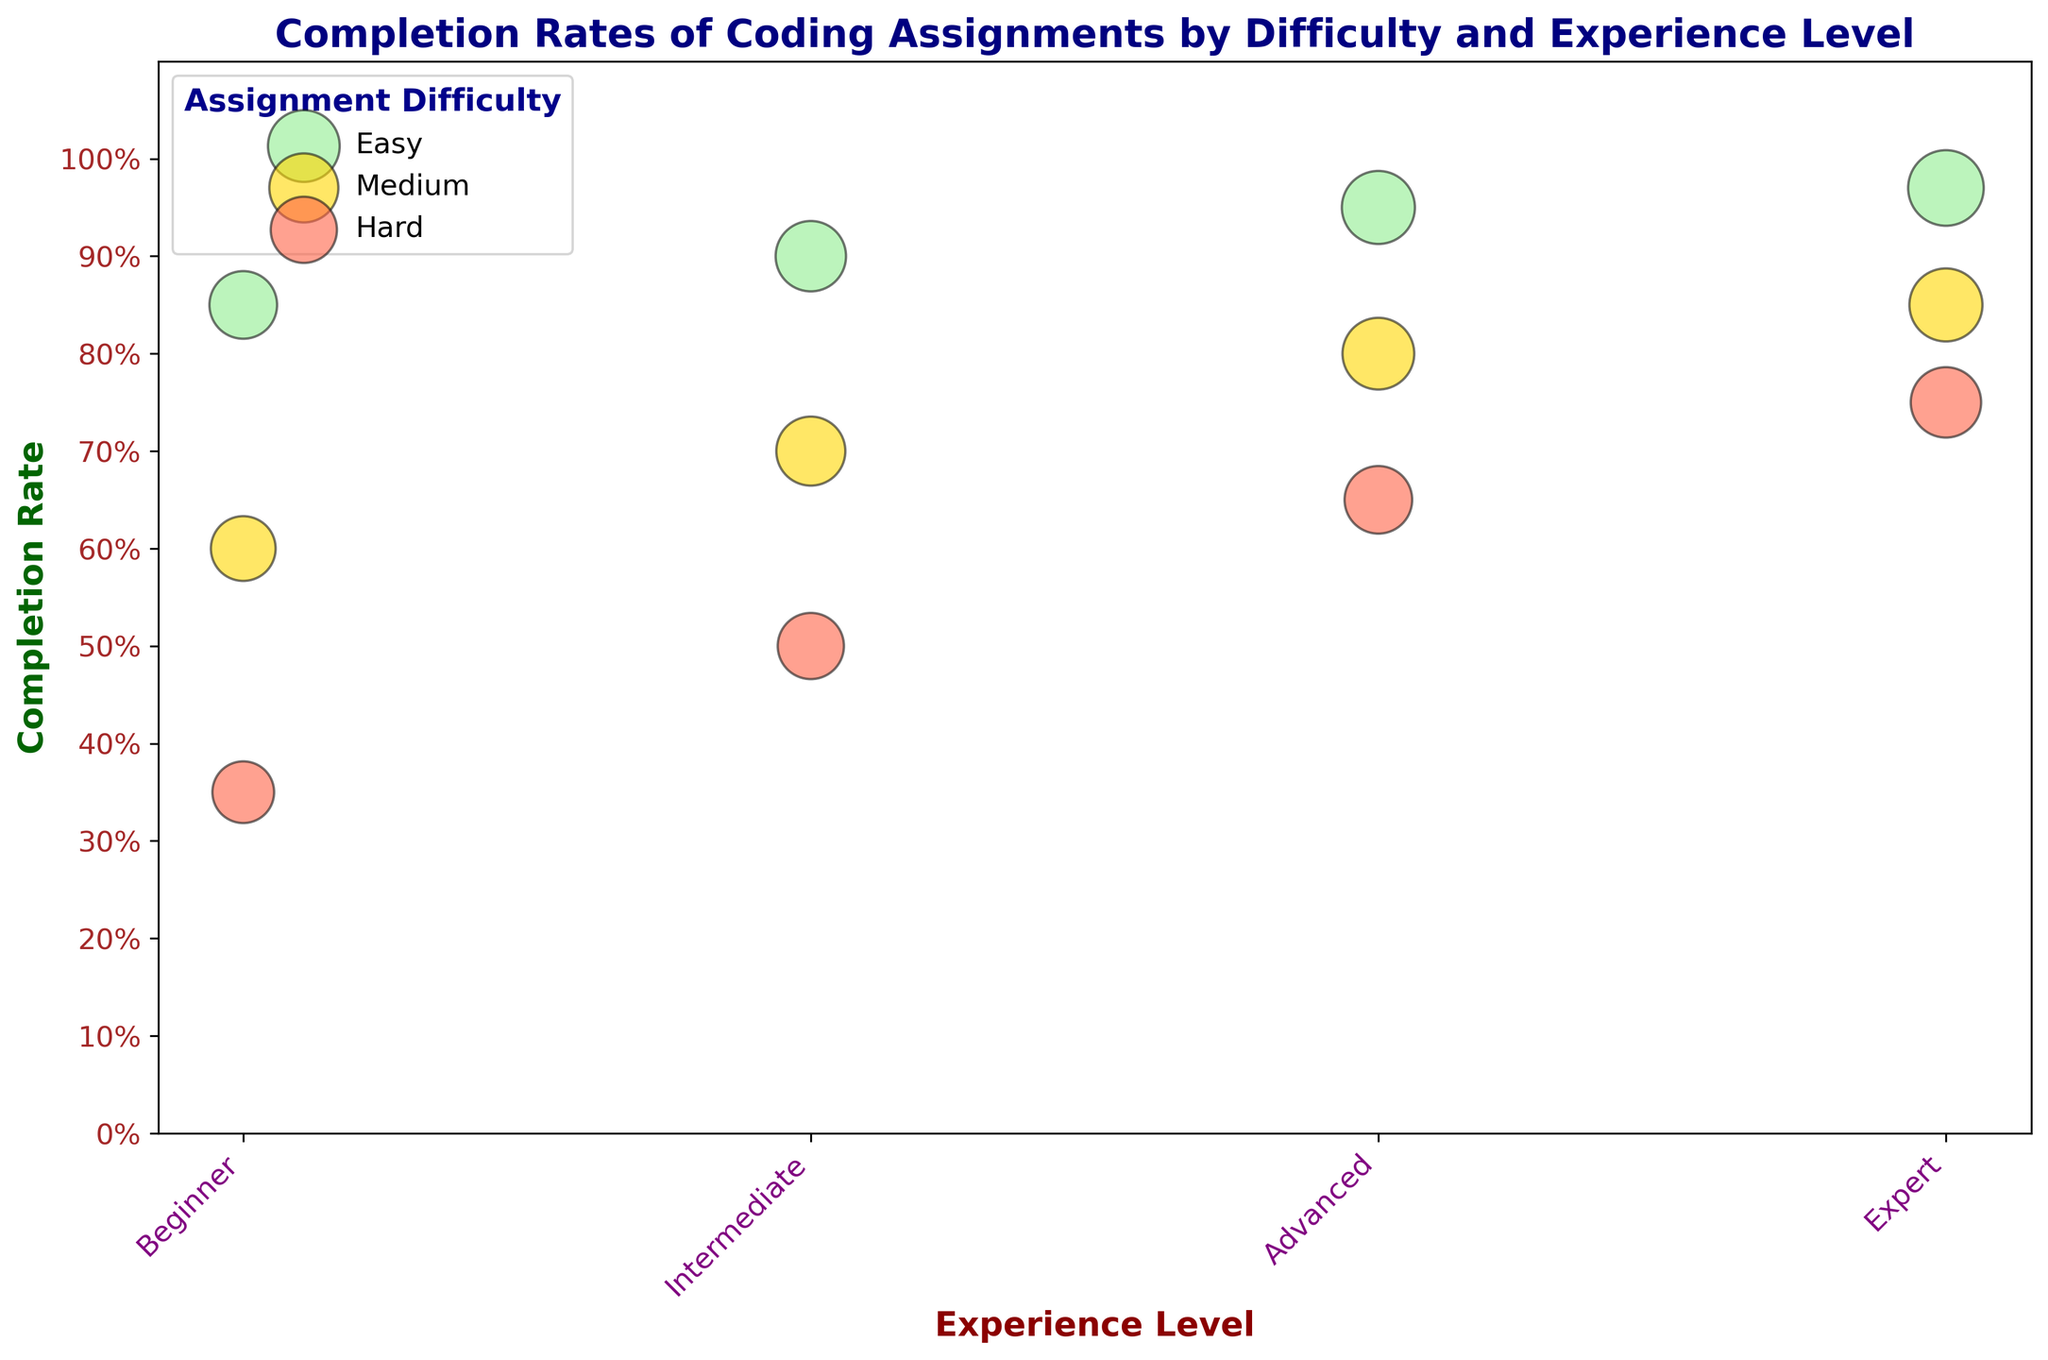What's the general trend in completion rates for 'Easy' assignments across different experience levels? To find this, look for the bubbles colored in light green. From the Beginner level to the Expert level, check the y-axis values corresponding to these bubbles. You'll notice an upward trend. For Beginners, the completion rate is 0.85, for Intermediates, it's 0.90, for Advanced, it's 0.95, and for Experts, it's 0.97. This shows a general increase in completion rates as experience levels rise.
Answer: Increasing Which difficulty level shows the most significant difference in completion rates between Beginners and Experts? We need to calculate the difference in completion rates for each difficulty level between Beginners and Experts. For 'Easy', it's 0.97 - 0.85 = 0.12. For 'Medium', it's 0.85 - 0.60 = 0.25. For 'Hard', it's 0.75 - 0.35 = 0.40. The 'Hard' assignments show the most significant difference of 0.40.
Answer: Hard What is the completion rate for 'Medium' difficulty for Advanced students? Look for the bubble labeled 'Medium' within the 'Advanced' experience level and check its position on the y-axis. The completion rate is positioned at 0.80.
Answer: 0.80 Compare the completion rates between 'Intermediate' and 'Advanced' students for 'Hard' assignments. Locate the bubbles labeled 'Hard' within the 'Intermediate' and 'Advanced' levels and compare their y-axis positions. The completion rate for 'Intermediate' is 0.50, and for 'Advanced' is 0.65. Comparing these values, Advanced students have a higher completion rate by 0.15 (0.65 - 0.50).
Answer: Advanced is higher by 0.15 Which experience level has the largest number of assignments for 'Medium' difficulty, and what is the size of the bubble in this context? We need to compare the sizes of bubbles labeled 'Medium' across all experience levels. The 'Expert' experience level has the largest bubble for 'Medium' difficulty, indicating the highest number of assignments. The specific bubble size isn't numerically visible in the plot, but 'Expert' for 'Medium' will have the largest bubble.
Answer: Expert For the 'Beginner' experience level, what is the average completion rate across all assignment difficulties? Average the completion rates for all difficulties for Beginner: (0.85 + 0.60 + 0.35) / 3. The sum is 1.80, and dividing by 3 gives the average, 0.60.
Answer: 0.60 What color represents the 'Medium' difficulty level in this plot, and what does it indicate about the completion rates? The 'Medium' difficulty level is represented by the color gold. To understand more, look at the completion rates labeled 'Medium' across various experience levels. The rates range from 0.60 to 0.85, indicating moderate difficulty.
Answer: Gold, moderate completion rates Describe the relative positions of completion rates for 'Easy', 'Medium', and 'Hard' assignments at the 'Expert' experience level. At the 'Expert' level, observe the positions of bubbles for 'Easy', 'Medium', and 'Hard': 'Easy' is at 0.97, 'Medium' at 0.85, and 'Hard' at 0.75 on the y-axis. The 'Easy' bubble is highest, followed by 'Medium' and 'Hard'.
Answer: Easy > Medium > Hard What is the highest completion rate observed in the plot, and for which difficulty and experience level is it? The highest y-axis value, which is closest to 1.0, represents the highest completion rate. The bubble representing 'Easy' assignments for 'Expert' students is at 0.97, indicating the highest completion rate.
Answer: Easy, Expert, 0.97 